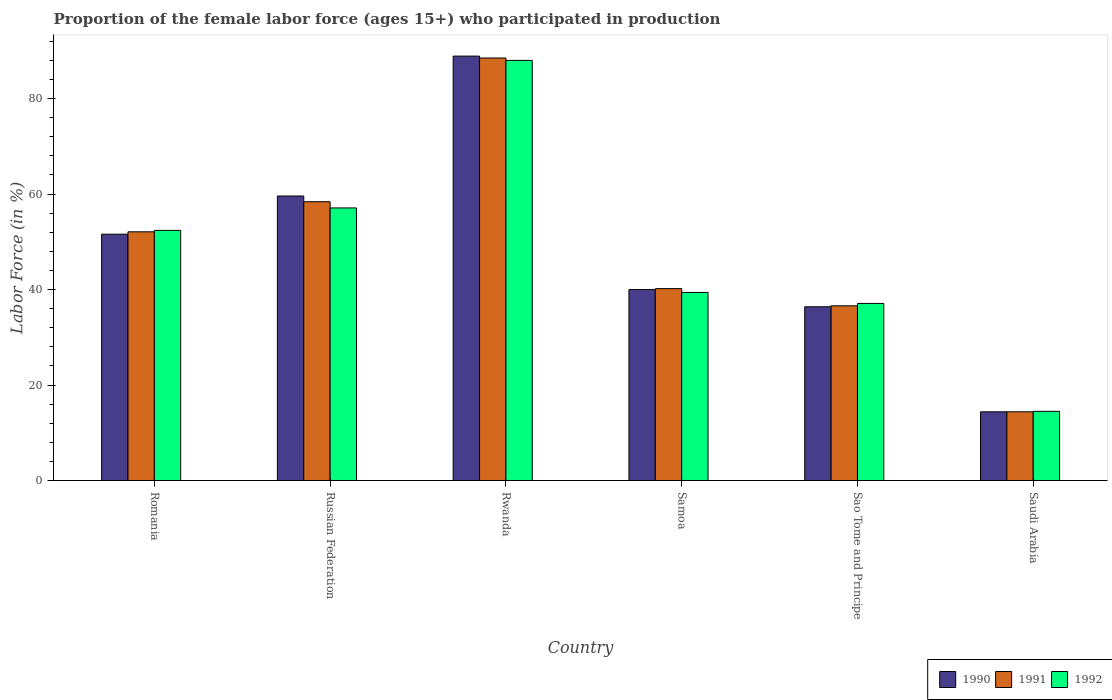How many different coloured bars are there?
Ensure brevity in your answer.  3. How many groups of bars are there?
Keep it short and to the point. 6. How many bars are there on the 3rd tick from the right?
Ensure brevity in your answer.  3. What is the label of the 4th group of bars from the left?
Keep it short and to the point. Samoa. Across all countries, what is the minimum proportion of the female labor force who participated in production in 1991?
Give a very brief answer. 14.4. In which country was the proportion of the female labor force who participated in production in 1990 maximum?
Your answer should be compact. Rwanda. In which country was the proportion of the female labor force who participated in production in 1990 minimum?
Provide a succinct answer. Saudi Arabia. What is the total proportion of the female labor force who participated in production in 1991 in the graph?
Offer a very short reply. 290.2. What is the difference between the proportion of the female labor force who participated in production in 1992 in Sao Tome and Principe and the proportion of the female labor force who participated in production in 1991 in Saudi Arabia?
Ensure brevity in your answer.  22.7. What is the average proportion of the female labor force who participated in production in 1992 per country?
Keep it short and to the point. 48.08. What is the difference between the proportion of the female labor force who participated in production of/in 1990 and proportion of the female labor force who participated in production of/in 1992 in Russian Federation?
Offer a terse response. 2.5. In how many countries, is the proportion of the female labor force who participated in production in 1992 greater than 76 %?
Your response must be concise. 1. What is the ratio of the proportion of the female labor force who participated in production in 1991 in Rwanda to that in Samoa?
Make the answer very short. 2.2. Is the proportion of the female labor force who participated in production in 1992 in Russian Federation less than that in Saudi Arabia?
Your response must be concise. No. Is the difference between the proportion of the female labor force who participated in production in 1990 in Russian Federation and Samoa greater than the difference between the proportion of the female labor force who participated in production in 1992 in Russian Federation and Samoa?
Your response must be concise. Yes. What is the difference between the highest and the second highest proportion of the female labor force who participated in production in 1990?
Provide a short and direct response. 37.3. What is the difference between the highest and the lowest proportion of the female labor force who participated in production in 1990?
Keep it short and to the point. 74.5. What does the 1st bar from the left in Samoa represents?
Keep it short and to the point. 1990. Is it the case that in every country, the sum of the proportion of the female labor force who participated in production in 1992 and proportion of the female labor force who participated in production in 1990 is greater than the proportion of the female labor force who participated in production in 1991?
Provide a succinct answer. Yes. How many bars are there?
Keep it short and to the point. 18. What is the difference between two consecutive major ticks on the Y-axis?
Make the answer very short. 20. Are the values on the major ticks of Y-axis written in scientific E-notation?
Your answer should be very brief. No. Does the graph contain any zero values?
Your response must be concise. No. What is the title of the graph?
Provide a short and direct response. Proportion of the female labor force (ages 15+) who participated in production. Does "1990" appear as one of the legend labels in the graph?
Offer a very short reply. Yes. What is the label or title of the X-axis?
Provide a succinct answer. Country. What is the Labor Force (in %) in 1990 in Romania?
Provide a succinct answer. 51.6. What is the Labor Force (in %) in 1991 in Romania?
Offer a terse response. 52.1. What is the Labor Force (in %) of 1992 in Romania?
Provide a short and direct response. 52.4. What is the Labor Force (in %) in 1990 in Russian Federation?
Your answer should be compact. 59.6. What is the Labor Force (in %) of 1991 in Russian Federation?
Ensure brevity in your answer.  58.4. What is the Labor Force (in %) in 1992 in Russian Federation?
Ensure brevity in your answer.  57.1. What is the Labor Force (in %) of 1990 in Rwanda?
Keep it short and to the point. 88.9. What is the Labor Force (in %) of 1991 in Rwanda?
Offer a terse response. 88.5. What is the Labor Force (in %) in 1991 in Samoa?
Provide a succinct answer. 40.2. What is the Labor Force (in %) of 1992 in Samoa?
Provide a succinct answer. 39.4. What is the Labor Force (in %) in 1990 in Sao Tome and Principe?
Your answer should be compact. 36.4. What is the Labor Force (in %) of 1991 in Sao Tome and Principe?
Ensure brevity in your answer.  36.6. What is the Labor Force (in %) in 1992 in Sao Tome and Principe?
Make the answer very short. 37.1. What is the Labor Force (in %) in 1990 in Saudi Arabia?
Your answer should be very brief. 14.4. What is the Labor Force (in %) in 1991 in Saudi Arabia?
Provide a short and direct response. 14.4. What is the Labor Force (in %) of 1992 in Saudi Arabia?
Your response must be concise. 14.5. Across all countries, what is the maximum Labor Force (in %) in 1990?
Offer a very short reply. 88.9. Across all countries, what is the maximum Labor Force (in %) of 1991?
Offer a very short reply. 88.5. Across all countries, what is the maximum Labor Force (in %) in 1992?
Keep it short and to the point. 88. Across all countries, what is the minimum Labor Force (in %) in 1990?
Give a very brief answer. 14.4. Across all countries, what is the minimum Labor Force (in %) in 1991?
Your response must be concise. 14.4. What is the total Labor Force (in %) of 1990 in the graph?
Keep it short and to the point. 290.9. What is the total Labor Force (in %) in 1991 in the graph?
Provide a short and direct response. 290.2. What is the total Labor Force (in %) of 1992 in the graph?
Ensure brevity in your answer.  288.5. What is the difference between the Labor Force (in %) in 1990 in Romania and that in Russian Federation?
Provide a short and direct response. -8. What is the difference between the Labor Force (in %) in 1992 in Romania and that in Russian Federation?
Offer a terse response. -4.7. What is the difference between the Labor Force (in %) of 1990 in Romania and that in Rwanda?
Your response must be concise. -37.3. What is the difference between the Labor Force (in %) in 1991 in Romania and that in Rwanda?
Provide a short and direct response. -36.4. What is the difference between the Labor Force (in %) in 1992 in Romania and that in Rwanda?
Your answer should be compact. -35.6. What is the difference between the Labor Force (in %) of 1991 in Romania and that in Samoa?
Offer a terse response. 11.9. What is the difference between the Labor Force (in %) of 1992 in Romania and that in Samoa?
Make the answer very short. 13. What is the difference between the Labor Force (in %) of 1990 in Romania and that in Saudi Arabia?
Your answer should be very brief. 37.2. What is the difference between the Labor Force (in %) of 1991 in Romania and that in Saudi Arabia?
Provide a short and direct response. 37.7. What is the difference between the Labor Force (in %) of 1992 in Romania and that in Saudi Arabia?
Make the answer very short. 37.9. What is the difference between the Labor Force (in %) in 1990 in Russian Federation and that in Rwanda?
Your answer should be compact. -29.3. What is the difference between the Labor Force (in %) in 1991 in Russian Federation and that in Rwanda?
Provide a succinct answer. -30.1. What is the difference between the Labor Force (in %) of 1992 in Russian Federation and that in Rwanda?
Give a very brief answer. -30.9. What is the difference between the Labor Force (in %) of 1990 in Russian Federation and that in Samoa?
Offer a very short reply. 19.6. What is the difference between the Labor Force (in %) of 1992 in Russian Federation and that in Samoa?
Your answer should be very brief. 17.7. What is the difference between the Labor Force (in %) in 1990 in Russian Federation and that in Sao Tome and Principe?
Your answer should be very brief. 23.2. What is the difference between the Labor Force (in %) in 1991 in Russian Federation and that in Sao Tome and Principe?
Provide a succinct answer. 21.8. What is the difference between the Labor Force (in %) in 1990 in Russian Federation and that in Saudi Arabia?
Your response must be concise. 45.2. What is the difference between the Labor Force (in %) of 1992 in Russian Federation and that in Saudi Arabia?
Give a very brief answer. 42.6. What is the difference between the Labor Force (in %) in 1990 in Rwanda and that in Samoa?
Give a very brief answer. 48.9. What is the difference between the Labor Force (in %) of 1991 in Rwanda and that in Samoa?
Provide a succinct answer. 48.3. What is the difference between the Labor Force (in %) in 1992 in Rwanda and that in Samoa?
Your answer should be compact. 48.6. What is the difference between the Labor Force (in %) of 1990 in Rwanda and that in Sao Tome and Principe?
Your response must be concise. 52.5. What is the difference between the Labor Force (in %) in 1991 in Rwanda and that in Sao Tome and Principe?
Ensure brevity in your answer.  51.9. What is the difference between the Labor Force (in %) in 1992 in Rwanda and that in Sao Tome and Principe?
Give a very brief answer. 50.9. What is the difference between the Labor Force (in %) of 1990 in Rwanda and that in Saudi Arabia?
Keep it short and to the point. 74.5. What is the difference between the Labor Force (in %) in 1991 in Rwanda and that in Saudi Arabia?
Ensure brevity in your answer.  74.1. What is the difference between the Labor Force (in %) of 1992 in Rwanda and that in Saudi Arabia?
Make the answer very short. 73.5. What is the difference between the Labor Force (in %) in 1991 in Samoa and that in Sao Tome and Principe?
Provide a succinct answer. 3.6. What is the difference between the Labor Force (in %) of 1992 in Samoa and that in Sao Tome and Principe?
Provide a succinct answer. 2.3. What is the difference between the Labor Force (in %) in 1990 in Samoa and that in Saudi Arabia?
Ensure brevity in your answer.  25.6. What is the difference between the Labor Force (in %) of 1991 in Samoa and that in Saudi Arabia?
Provide a succinct answer. 25.8. What is the difference between the Labor Force (in %) in 1992 in Samoa and that in Saudi Arabia?
Provide a short and direct response. 24.9. What is the difference between the Labor Force (in %) in 1992 in Sao Tome and Principe and that in Saudi Arabia?
Provide a short and direct response. 22.6. What is the difference between the Labor Force (in %) of 1990 in Romania and the Labor Force (in %) of 1991 in Russian Federation?
Ensure brevity in your answer.  -6.8. What is the difference between the Labor Force (in %) of 1990 in Romania and the Labor Force (in %) of 1992 in Russian Federation?
Offer a terse response. -5.5. What is the difference between the Labor Force (in %) of 1991 in Romania and the Labor Force (in %) of 1992 in Russian Federation?
Offer a very short reply. -5. What is the difference between the Labor Force (in %) of 1990 in Romania and the Labor Force (in %) of 1991 in Rwanda?
Keep it short and to the point. -36.9. What is the difference between the Labor Force (in %) in 1990 in Romania and the Labor Force (in %) in 1992 in Rwanda?
Your answer should be very brief. -36.4. What is the difference between the Labor Force (in %) of 1991 in Romania and the Labor Force (in %) of 1992 in Rwanda?
Offer a very short reply. -35.9. What is the difference between the Labor Force (in %) in 1990 in Romania and the Labor Force (in %) in 1991 in Samoa?
Ensure brevity in your answer.  11.4. What is the difference between the Labor Force (in %) of 1990 in Romania and the Labor Force (in %) of 1992 in Samoa?
Provide a short and direct response. 12.2. What is the difference between the Labor Force (in %) in 1990 in Romania and the Labor Force (in %) in 1991 in Saudi Arabia?
Provide a succinct answer. 37.2. What is the difference between the Labor Force (in %) in 1990 in Romania and the Labor Force (in %) in 1992 in Saudi Arabia?
Provide a short and direct response. 37.1. What is the difference between the Labor Force (in %) in 1991 in Romania and the Labor Force (in %) in 1992 in Saudi Arabia?
Offer a terse response. 37.6. What is the difference between the Labor Force (in %) in 1990 in Russian Federation and the Labor Force (in %) in 1991 in Rwanda?
Offer a terse response. -28.9. What is the difference between the Labor Force (in %) of 1990 in Russian Federation and the Labor Force (in %) of 1992 in Rwanda?
Provide a succinct answer. -28.4. What is the difference between the Labor Force (in %) of 1991 in Russian Federation and the Labor Force (in %) of 1992 in Rwanda?
Keep it short and to the point. -29.6. What is the difference between the Labor Force (in %) in 1990 in Russian Federation and the Labor Force (in %) in 1992 in Samoa?
Offer a very short reply. 20.2. What is the difference between the Labor Force (in %) of 1991 in Russian Federation and the Labor Force (in %) of 1992 in Samoa?
Give a very brief answer. 19. What is the difference between the Labor Force (in %) in 1991 in Russian Federation and the Labor Force (in %) in 1992 in Sao Tome and Principe?
Offer a terse response. 21.3. What is the difference between the Labor Force (in %) of 1990 in Russian Federation and the Labor Force (in %) of 1991 in Saudi Arabia?
Make the answer very short. 45.2. What is the difference between the Labor Force (in %) of 1990 in Russian Federation and the Labor Force (in %) of 1992 in Saudi Arabia?
Your response must be concise. 45.1. What is the difference between the Labor Force (in %) of 1991 in Russian Federation and the Labor Force (in %) of 1992 in Saudi Arabia?
Provide a short and direct response. 43.9. What is the difference between the Labor Force (in %) in 1990 in Rwanda and the Labor Force (in %) in 1991 in Samoa?
Keep it short and to the point. 48.7. What is the difference between the Labor Force (in %) of 1990 in Rwanda and the Labor Force (in %) of 1992 in Samoa?
Ensure brevity in your answer.  49.5. What is the difference between the Labor Force (in %) in 1991 in Rwanda and the Labor Force (in %) in 1992 in Samoa?
Ensure brevity in your answer.  49.1. What is the difference between the Labor Force (in %) in 1990 in Rwanda and the Labor Force (in %) in 1991 in Sao Tome and Principe?
Offer a very short reply. 52.3. What is the difference between the Labor Force (in %) in 1990 in Rwanda and the Labor Force (in %) in 1992 in Sao Tome and Principe?
Your answer should be compact. 51.8. What is the difference between the Labor Force (in %) of 1991 in Rwanda and the Labor Force (in %) of 1992 in Sao Tome and Principe?
Keep it short and to the point. 51.4. What is the difference between the Labor Force (in %) of 1990 in Rwanda and the Labor Force (in %) of 1991 in Saudi Arabia?
Keep it short and to the point. 74.5. What is the difference between the Labor Force (in %) of 1990 in Rwanda and the Labor Force (in %) of 1992 in Saudi Arabia?
Provide a short and direct response. 74.4. What is the difference between the Labor Force (in %) in 1991 in Rwanda and the Labor Force (in %) in 1992 in Saudi Arabia?
Give a very brief answer. 74. What is the difference between the Labor Force (in %) of 1990 in Samoa and the Labor Force (in %) of 1991 in Sao Tome and Principe?
Provide a succinct answer. 3.4. What is the difference between the Labor Force (in %) of 1990 in Samoa and the Labor Force (in %) of 1991 in Saudi Arabia?
Ensure brevity in your answer.  25.6. What is the difference between the Labor Force (in %) in 1990 in Samoa and the Labor Force (in %) in 1992 in Saudi Arabia?
Provide a succinct answer. 25.5. What is the difference between the Labor Force (in %) in 1991 in Samoa and the Labor Force (in %) in 1992 in Saudi Arabia?
Your answer should be very brief. 25.7. What is the difference between the Labor Force (in %) of 1990 in Sao Tome and Principe and the Labor Force (in %) of 1992 in Saudi Arabia?
Your response must be concise. 21.9. What is the difference between the Labor Force (in %) of 1991 in Sao Tome and Principe and the Labor Force (in %) of 1992 in Saudi Arabia?
Provide a short and direct response. 22.1. What is the average Labor Force (in %) of 1990 per country?
Your response must be concise. 48.48. What is the average Labor Force (in %) of 1991 per country?
Offer a very short reply. 48.37. What is the average Labor Force (in %) of 1992 per country?
Give a very brief answer. 48.08. What is the difference between the Labor Force (in %) in 1990 and Labor Force (in %) in 1992 in Romania?
Provide a succinct answer. -0.8. What is the difference between the Labor Force (in %) of 1991 and Labor Force (in %) of 1992 in Romania?
Offer a very short reply. -0.3. What is the difference between the Labor Force (in %) in 1990 and Labor Force (in %) in 1991 in Russian Federation?
Your answer should be compact. 1.2. What is the difference between the Labor Force (in %) in 1990 and Labor Force (in %) in 1992 in Russian Federation?
Ensure brevity in your answer.  2.5. What is the difference between the Labor Force (in %) of 1991 and Labor Force (in %) of 1992 in Russian Federation?
Provide a succinct answer. 1.3. What is the difference between the Labor Force (in %) in 1990 and Labor Force (in %) in 1991 in Rwanda?
Keep it short and to the point. 0.4. What is the difference between the Labor Force (in %) in 1990 and Labor Force (in %) in 1992 in Rwanda?
Offer a very short reply. 0.9. What is the difference between the Labor Force (in %) of 1990 and Labor Force (in %) of 1992 in Sao Tome and Principe?
Provide a short and direct response. -0.7. What is the difference between the Labor Force (in %) of 1991 and Labor Force (in %) of 1992 in Saudi Arabia?
Ensure brevity in your answer.  -0.1. What is the ratio of the Labor Force (in %) in 1990 in Romania to that in Russian Federation?
Make the answer very short. 0.87. What is the ratio of the Labor Force (in %) of 1991 in Romania to that in Russian Federation?
Offer a terse response. 0.89. What is the ratio of the Labor Force (in %) of 1992 in Romania to that in Russian Federation?
Offer a terse response. 0.92. What is the ratio of the Labor Force (in %) in 1990 in Romania to that in Rwanda?
Offer a terse response. 0.58. What is the ratio of the Labor Force (in %) in 1991 in Romania to that in Rwanda?
Provide a short and direct response. 0.59. What is the ratio of the Labor Force (in %) of 1992 in Romania to that in Rwanda?
Provide a short and direct response. 0.6. What is the ratio of the Labor Force (in %) of 1990 in Romania to that in Samoa?
Your response must be concise. 1.29. What is the ratio of the Labor Force (in %) in 1991 in Romania to that in Samoa?
Your answer should be very brief. 1.3. What is the ratio of the Labor Force (in %) of 1992 in Romania to that in Samoa?
Ensure brevity in your answer.  1.33. What is the ratio of the Labor Force (in %) of 1990 in Romania to that in Sao Tome and Principe?
Provide a short and direct response. 1.42. What is the ratio of the Labor Force (in %) in 1991 in Romania to that in Sao Tome and Principe?
Offer a terse response. 1.42. What is the ratio of the Labor Force (in %) in 1992 in Romania to that in Sao Tome and Principe?
Give a very brief answer. 1.41. What is the ratio of the Labor Force (in %) of 1990 in Romania to that in Saudi Arabia?
Make the answer very short. 3.58. What is the ratio of the Labor Force (in %) of 1991 in Romania to that in Saudi Arabia?
Your answer should be very brief. 3.62. What is the ratio of the Labor Force (in %) of 1992 in Romania to that in Saudi Arabia?
Make the answer very short. 3.61. What is the ratio of the Labor Force (in %) of 1990 in Russian Federation to that in Rwanda?
Your answer should be compact. 0.67. What is the ratio of the Labor Force (in %) in 1991 in Russian Federation to that in Rwanda?
Your answer should be very brief. 0.66. What is the ratio of the Labor Force (in %) of 1992 in Russian Federation to that in Rwanda?
Give a very brief answer. 0.65. What is the ratio of the Labor Force (in %) of 1990 in Russian Federation to that in Samoa?
Give a very brief answer. 1.49. What is the ratio of the Labor Force (in %) of 1991 in Russian Federation to that in Samoa?
Offer a terse response. 1.45. What is the ratio of the Labor Force (in %) in 1992 in Russian Federation to that in Samoa?
Offer a very short reply. 1.45. What is the ratio of the Labor Force (in %) of 1990 in Russian Federation to that in Sao Tome and Principe?
Provide a succinct answer. 1.64. What is the ratio of the Labor Force (in %) of 1991 in Russian Federation to that in Sao Tome and Principe?
Your response must be concise. 1.6. What is the ratio of the Labor Force (in %) in 1992 in Russian Federation to that in Sao Tome and Principe?
Offer a terse response. 1.54. What is the ratio of the Labor Force (in %) in 1990 in Russian Federation to that in Saudi Arabia?
Give a very brief answer. 4.14. What is the ratio of the Labor Force (in %) of 1991 in Russian Federation to that in Saudi Arabia?
Keep it short and to the point. 4.06. What is the ratio of the Labor Force (in %) of 1992 in Russian Federation to that in Saudi Arabia?
Keep it short and to the point. 3.94. What is the ratio of the Labor Force (in %) of 1990 in Rwanda to that in Samoa?
Ensure brevity in your answer.  2.22. What is the ratio of the Labor Force (in %) in 1991 in Rwanda to that in Samoa?
Make the answer very short. 2.2. What is the ratio of the Labor Force (in %) of 1992 in Rwanda to that in Samoa?
Provide a succinct answer. 2.23. What is the ratio of the Labor Force (in %) in 1990 in Rwanda to that in Sao Tome and Principe?
Ensure brevity in your answer.  2.44. What is the ratio of the Labor Force (in %) in 1991 in Rwanda to that in Sao Tome and Principe?
Give a very brief answer. 2.42. What is the ratio of the Labor Force (in %) of 1992 in Rwanda to that in Sao Tome and Principe?
Provide a succinct answer. 2.37. What is the ratio of the Labor Force (in %) of 1990 in Rwanda to that in Saudi Arabia?
Your answer should be very brief. 6.17. What is the ratio of the Labor Force (in %) in 1991 in Rwanda to that in Saudi Arabia?
Your response must be concise. 6.15. What is the ratio of the Labor Force (in %) of 1992 in Rwanda to that in Saudi Arabia?
Give a very brief answer. 6.07. What is the ratio of the Labor Force (in %) in 1990 in Samoa to that in Sao Tome and Principe?
Give a very brief answer. 1.1. What is the ratio of the Labor Force (in %) in 1991 in Samoa to that in Sao Tome and Principe?
Provide a short and direct response. 1.1. What is the ratio of the Labor Force (in %) of 1992 in Samoa to that in Sao Tome and Principe?
Keep it short and to the point. 1.06. What is the ratio of the Labor Force (in %) of 1990 in Samoa to that in Saudi Arabia?
Make the answer very short. 2.78. What is the ratio of the Labor Force (in %) of 1991 in Samoa to that in Saudi Arabia?
Ensure brevity in your answer.  2.79. What is the ratio of the Labor Force (in %) in 1992 in Samoa to that in Saudi Arabia?
Provide a succinct answer. 2.72. What is the ratio of the Labor Force (in %) of 1990 in Sao Tome and Principe to that in Saudi Arabia?
Give a very brief answer. 2.53. What is the ratio of the Labor Force (in %) in 1991 in Sao Tome and Principe to that in Saudi Arabia?
Provide a succinct answer. 2.54. What is the ratio of the Labor Force (in %) of 1992 in Sao Tome and Principe to that in Saudi Arabia?
Ensure brevity in your answer.  2.56. What is the difference between the highest and the second highest Labor Force (in %) of 1990?
Your answer should be compact. 29.3. What is the difference between the highest and the second highest Labor Force (in %) of 1991?
Provide a short and direct response. 30.1. What is the difference between the highest and the second highest Labor Force (in %) in 1992?
Offer a terse response. 30.9. What is the difference between the highest and the lowest Labor Force (in %) of 1990?
Your response must be concise. 74.5. What is the difference between the highest and the lowest Labor Force (in %) of 1991?
Your answer should be very brief. 74.1. What is the difference between the highest and the lowest Labor Force (in %) of 1992?
Provide a short and direct response. 73.5. 